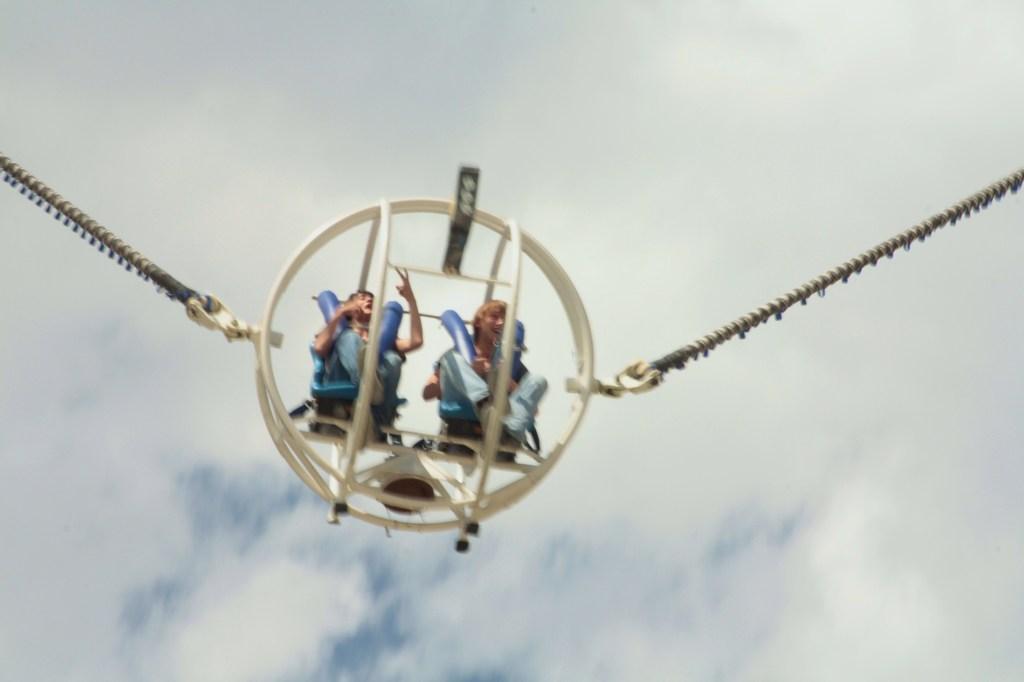In one or two sentences, can you explain what this image depicts? In this image I can see two people sitting on the ride and there are ropes attached to it. In the background I can see the clouds and the sky. 